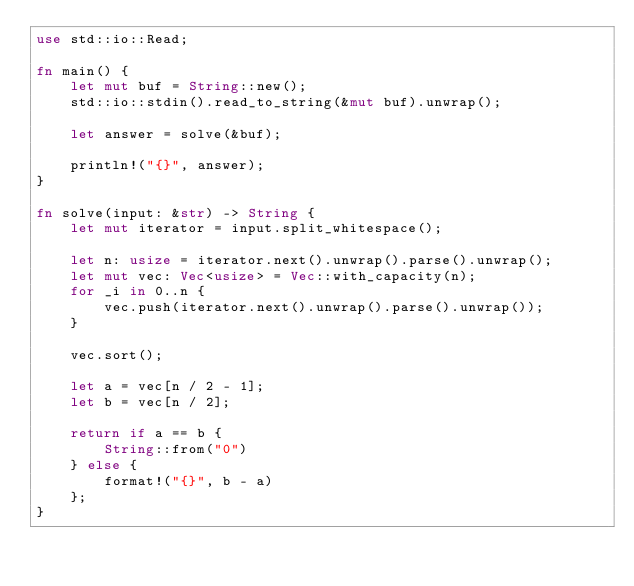<code> <loc_0><loc_0><loc_500><loc_500><_Rust_>use std::io::Read;

fn main() {
    let mut buf = String::new();
    std::io::stdin().read_to_string(&mut buf).unwrap();

    let answer = solve(&buf);

    println!("{}", answer);
}

fn solve(input: &str) -> String {
    let mut iterator = input.split_whitespace();

    let n: usize = iterator.next().unwrap().parse().unwrap();
    let mut vec: Vec<usize> = Vec::with_capacity(n);
    for _i in 0..n {
        vec.push(iterator.next().unwrap().parse().unwrap());
    }

    vec.sort();

    let a = vec[n / 2 - 1];
    let b = vec[n / 2];

    return if a == b {
        String::from("0")
    } else {
        format!("{}", b - a)
    };
}
</code> 